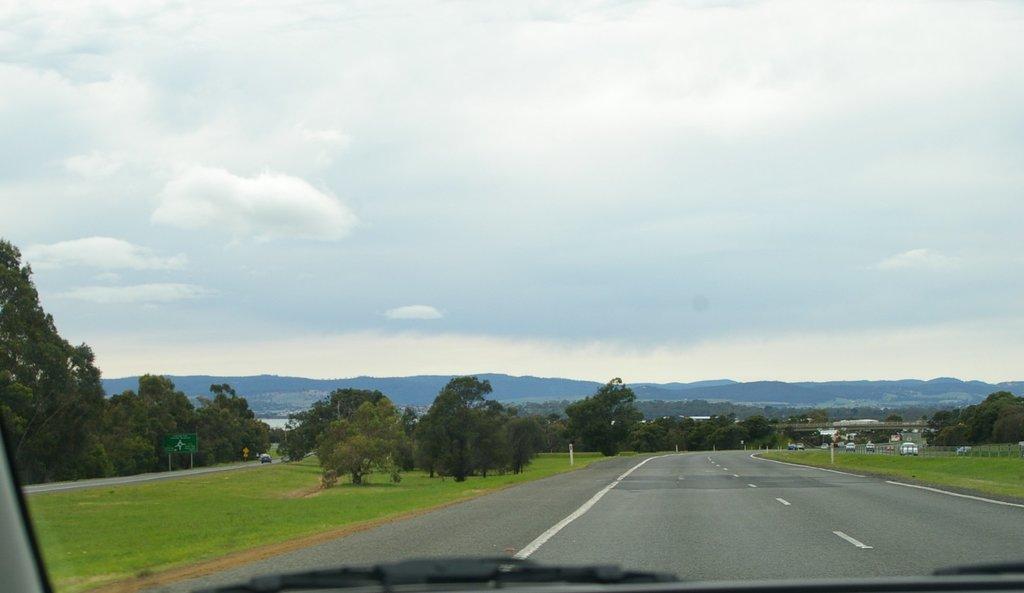Could you give a brief overview of what you see in this image? In this picture we can see some trees and grass, we can see wiper at the bottom, there are some vehicles traveling on the road here, on the left side there is a board, we can see sky at the top of the picture. 